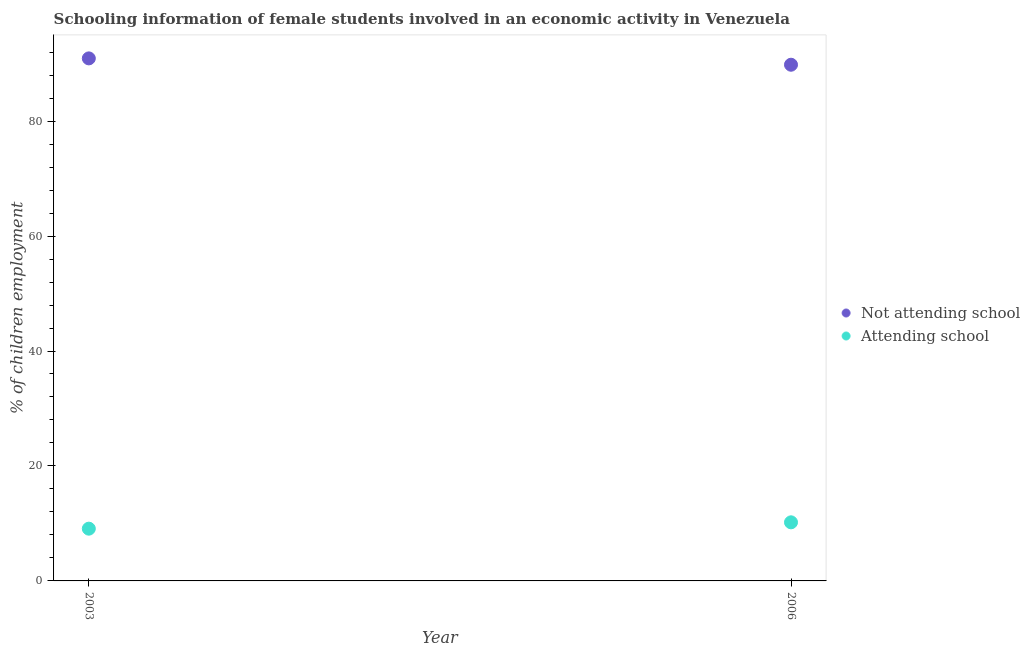What is the percentage of employed females who are attending school in 2003?
Provide a succinct answer. 9.09. Across all years, what is the maximum percentage of employed females who are not attending school?
Provide a short and direct response. 90.91. Across all years, what is the minimum percentage of employed females who are attending school?
Offer a terse response. 9.09. In which year was the percentage of employed females who are attending school maximum?
Ensure brevity in your answer.  2006. What is the total percentage of employed females who are attending school in the graph?
Your answer should be very brief. 19.28. What is the difference between the percentage of employed females who are attending school in 2003 and that in 2006?
Provide a short and direct response. -1.1. What is the difference between the percentage of employed females who are attending school in 2003 and the percentage of employed females who are not attending school in 2006?
Make the answer very short. -80.72. What is the average percentage of employed females who are not attending school per year?
Keep it short and to the point. 90.36. In the year 2006, what is the difference between the percentage of employed females who are not attending school and percentage of employed females who are attending school?
Provide a short and direct response. 79.61. What is the ratio of the percentage of employed females who are not attending school in 2003 to that in 2006?
Provide a short and direct response. 1.01. Is the percentage of employed females who are not attending school in 2003 less than that in 2006?
Provide a short and direct response. No. Is the percentage of employed females who are attending school strictly greater than the percentage of employed females who are not attending school over the years?
Keep it short and to the point. No. Is the percentage of employed females who are not attending school strictly less than the percentage of employed females who are attending school over the years?
Make the answer very short. No. How many years are there in the graph?
Provide a succinct answer. 2. Are the values on the major ticks of Y-axis written in scientific E-notation?
Your answer should be compact. No. Does the graph contain grids?
Make the answer very short. No. What is the title of the graph?
Provide a succinct answer. Schooling information of female students involved in an economic activity in Venezuela. What is the label or title of the X-axis?
Offer a very short reply. Year. What is the label or title of the Y-axis?
Your answer should be very brief. % of children employment. What is the % of children employment in Not attending school in 2003?
Ensure brevity in your answer.  90.91. What is the % of children employment of Attending school in 2003?
Give a very brief answer. 9.09. What is the % of children employment of Not attending school in 2006?
Provide a succinct answer. 89.81. What is the % of children employment in Attending school in 2006?
Provide a succinct answer. 10.19. Across all years, what is the maximum % of children employment in Not attending school?
Make the answer very short. 90.91. Across all years, what is the maximum % of children employment in Attending school?
Give a very brief answer. 10.19. Across all years, what is the minimum % of children employment of Not attending school?
Make the answer very short. 89.81. Across all years, what is the minimum % of children employment of Attending school?
Offer a terse response. 9.09. What is the total % of children employment of Not attending school in the graph?
Ensure brevity in your answer.  180.72. What is the total % of children employment in Attending school in the graph?
Your response must be concise. 19.29. What is the difference between the % of children employment in Not attending school in 2003 and that in 2006?
Provide a short and direct response. 1.1. What is the difference between the % of children employment of Attending school in 2003 and that in 2006?
Ensure brevity in your answer.  -1.1. What is the difference between the % of children employment in Not attending school in 2003 and the % of children employment in Attending school in 2006?
Provide a short and direct response. 80.72. What is the average % of children employment of Not attending school per year?
Provide a succinct answer. 90.36. What is the average % of children employment of Attending school per year?
Make the answer very short. 9.64. In the year 2003, what is the difference between the % of children employment in Not attending school and % of children employment in Attending school?
Ensure brevity in your answer.  81.82. In the year 2006, what is the difference between the % of children employment of Not attending school and % of children employment of Attending school?
Your response must be concise. 79.61. What is the ratio of the % of children employment of Not attending school in 2003 to that in 2006?
Provide a succinct answer. 1.01. What is the ratio of the % of children employment in Attending school in 2003 to that in 2006?
Offer a very short reply. 0.89. What is the difference between the highest and the second highest % of children employment in Not attending school?
Offer a very short reply. 1.1. What is the difference between the highest and the second highest % of children employment in Attending school?
Your answer should be very brief. 1.1. What is the difference between the highest and the lowest % of children employment in Not attending school?
Ensure brevity in your answer.  1.1. What is the difference between the highest and the lowest % of children employment in Attending school?
Provide a succinct answer. 1.1. 